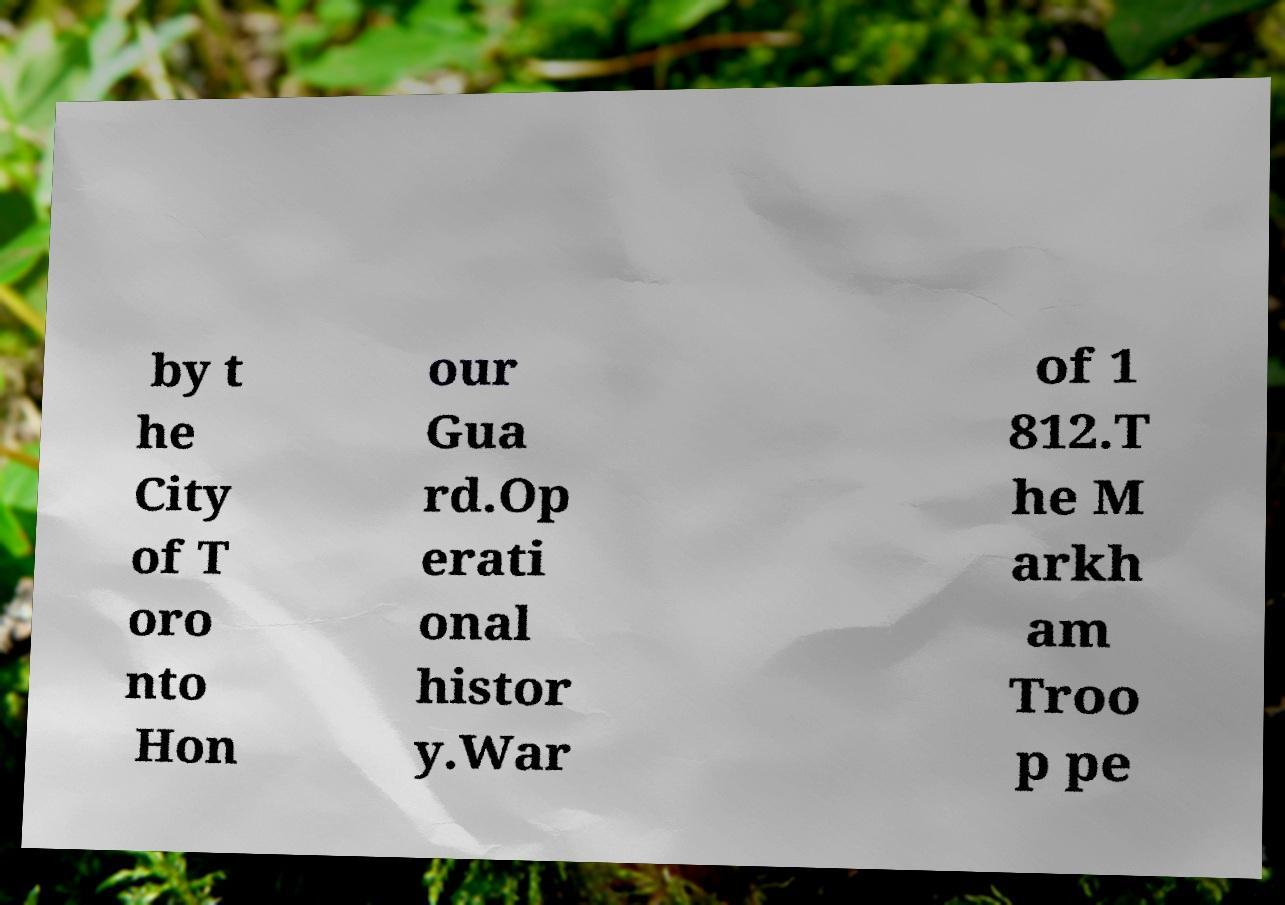Please identify and transcribe the text found in this image. by t he City of T oro nto Hon our Gua rd.Op erati onal histor y.War of 1 812.T he M arkh am Troo p pe 